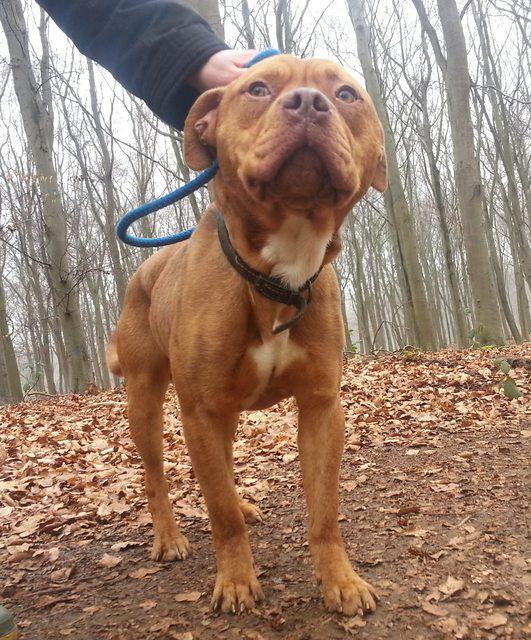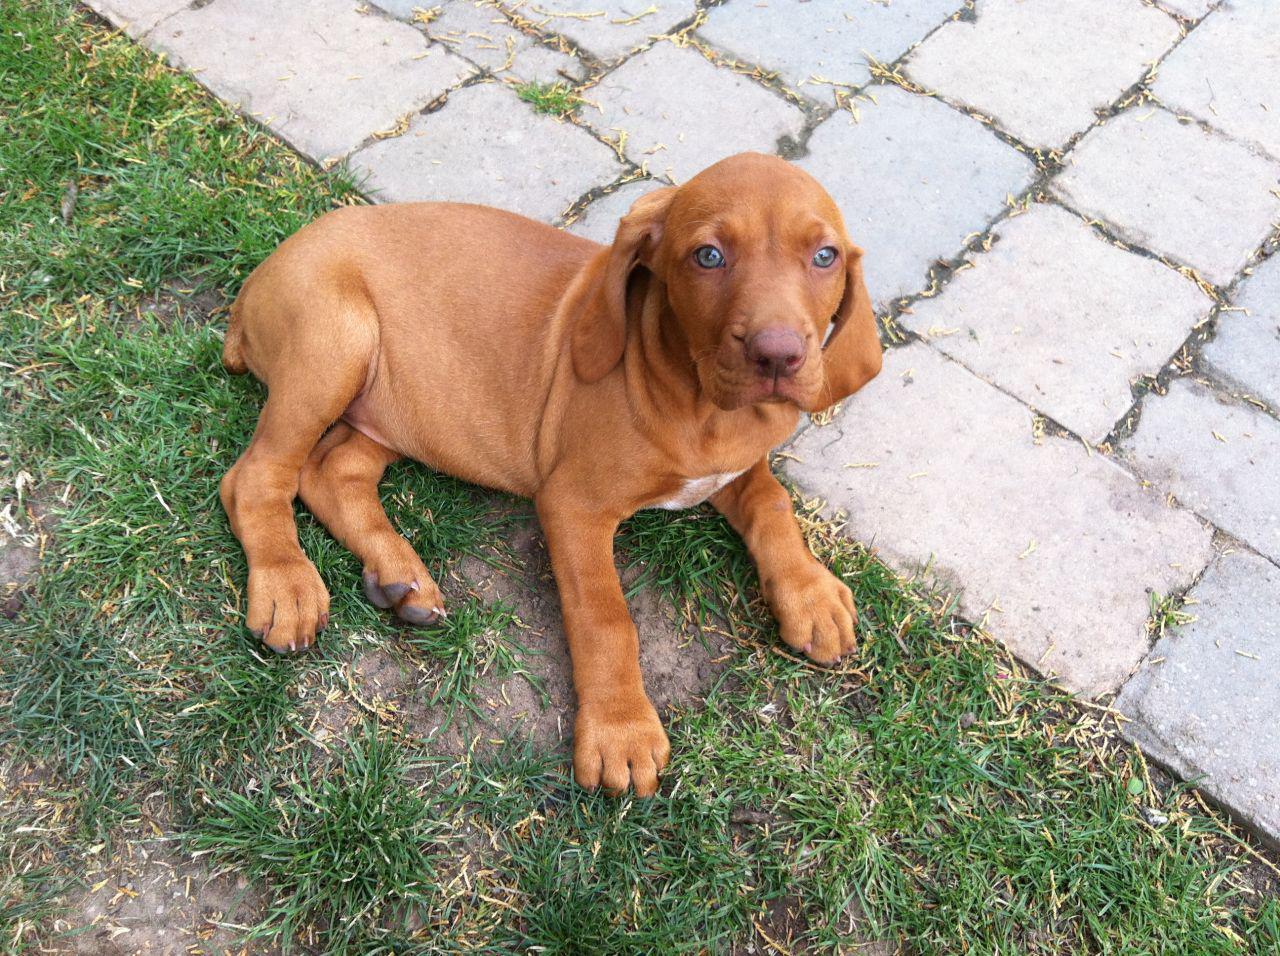The first image is the image on the left, the second image is the image on the right. Evaluate the accuracy of this statement regarding the images: "One dog is standing.". Is it true? Answer yes or no. Yes. 